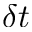<formula> <loc_0><loc_0><loc_500><loc_500>\delta t</formula> 